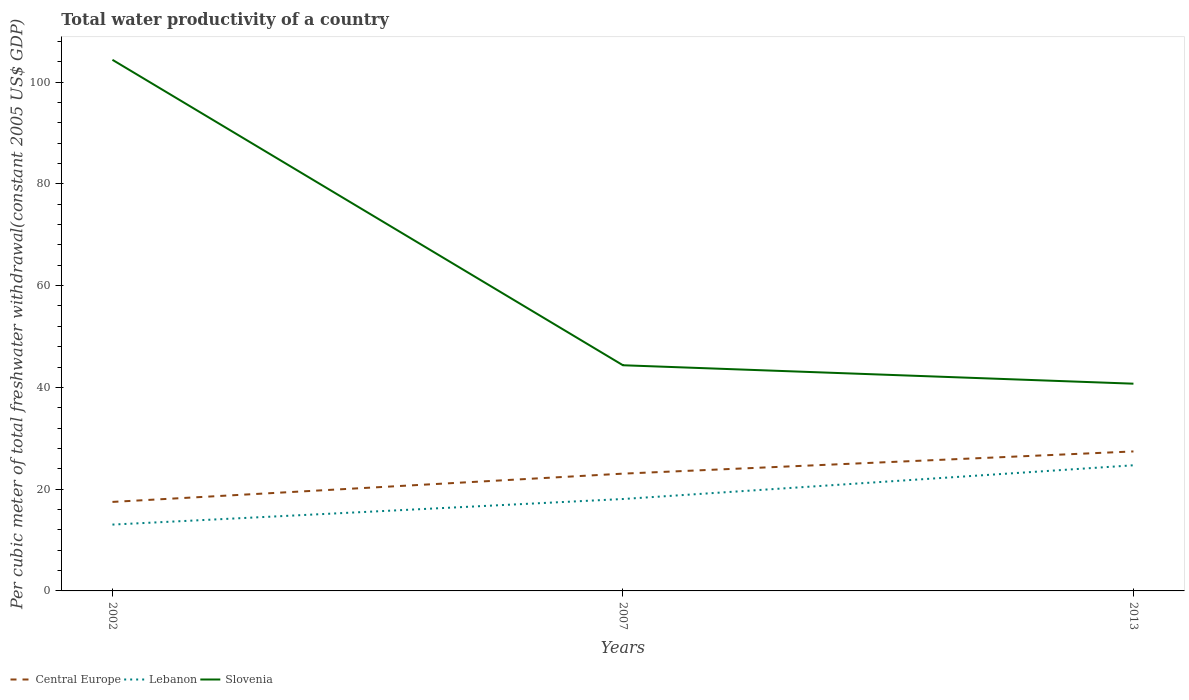How many different coloured lines are there?
Offer a very short reply. 3. Does the line corresponding to Lebanon intersect with the line corresponding to Central Europe?
Give a very brief answer. No. Is the number of lines equal to the number of legend labels?
Offer a very short reply. Yes. Across all years, what is the maximum total water productivity in Central Europe?
Offer a very short reply. 17.49. What is the total total water productivity in Central Europe in the graph?
Your answer should be very brief. -4.37. What is the difference between the highest and the second highest total water productivity in Slovenia?
Offer a terse response. 63.65. What is the difference between the highest and the lowest total water productivity in Central Europe?
Give a very brief answer. 2. How many lines are there?
Your answer should be compact. 3. How many years are there in the graph?
Make the answer very short. 3. What is the difference between two consecutive major ticks on the Y-axis?
Your response must be concise. 20. Are the values on the major ticks of Y-axis written in scientific E-notation?
Ensure brevity in your answer.  No. How are the legend labels stacked?
Offer a terse response. Horizontal. What is the title of the graph?
Your response must be concise. Total water productivity of a country. Does "Bahrain" appear as one of the legend labels in the graph?
Your answer should be compact. No. What is the label or title of the X-axis?
Ensure brevity in your answer.  Years. What is the label or title of the Y-axis?
Make the answer very short. Per cubic meter of total freshwater withdrawal(constant 2005 US$ GDP). What is the Per cubic meter of total freshwater withdrawal(constant 2005 US$ GDP) of Central Europe in 2002?
Provide a short and direct response. 17.49. What is the Per cubic meter of total freshwater withdrawal(constant 2005 US$ GDP) of Lebanon in 2002?
Your answer should be very brief. 13.04. What is the Per cubic meter of total freshwater withdrawal(constant 2005 US$ GDP) of Slovenia in 2002?
Ensure brevity in your answer.  104.38. What is the Per cubic meter of total freshwater withdrawal(constant 2005 US$ GDP) in Central Europe in 2007?
Your answer should be compact. 23.05. What is the Per cubic meter of total freshwater withdrawal(constant 2005 US$ GDP) in Lebanon in 2007?
Give a very brief answer. 18.06. What is the Per cubic meter of total freshwater withdrawal(constant 2005 US$ GDP) of Slovenia in 2007?
Ensure brevity in your answer.  44.35. What is the Per cubic meter of total freshwater withdrawal(constant 2005 US$ GDP) in Central Europe in 2013?
Offer a very short reply. 27.41. What is the Per cubic meter of total freshwater withdrawal(constant 2005 US$ GDP) in Lebanon in 2013?
Your answer should be compact. 24.69. What is the Per cubic meter of total freshwater withdrawal(constant 2005 US$ GDP) in Slovenia in 2013?
Offer a terse response. 40.73. Across all years, what is the maximum Per cubic meter of total freshwater withdrawal(constant 2005 US$ GDP) in Central Europe?
Keep it short and to the point. 27.41. Across all years, what is the maximum Per cubic meter of total freshwater withdrawal(constant 2005 US$ GDP) in Lebanon?
Ensure brevity in your answer.  24.69. Across all years, what is the maximum Per cubic meter of total freshwater withdrawal(constant 2005 US$ GDP) of Slovenia?
Provide a succinct answer. 104.38. Across all years, what is the minimum Per cubic meter of total freshwater withdrawal(constant 2005 US$ GDP) of Central Europe?
Make the answer very short. 17.49. Across all years, what is the minimum Per cubic meter of total freshwater withdrawal(constant 2005 US$ GDP) of Lebanon?
Offer a terse response. 13.04. Across all years, what is the minimum Per cubic meter of total freshwater withdrawal(constant 2005 US$ GDP) in Slovenia?
Offer a very short reply. 40.73. What is the total Per cubic meter of total freshwater withdrawal(constant 2005 US$ GDP) of Central Europe in the graph?
Offer a very short reply. 67.95. What is the total Per cubic meter of total freshwater withdrawal(constant 2005 US$ GDP) in Lebanon in the graph?
Your answer should be compact. 55.79. What is the total Per cubic meter of total freshwater withdrawal(constant 2005 US$ GDP) of Slovenia in the graph?
Keep it short and to the point. 189.45. What is the difference between the Per cubic meter of total freshwater withdrawal(constant 2005 US$ GDP) in Central Europe in 2002 and that in 2007?
Provide a succinct answer. -5.56. What is the difference between the Per cubic meter of total freshwater withdrawal(constant 2005 US$ GDP) in Lebanon in 2002 and that in 2007?
Your response must be concise. -5.03. What is the difference between the Per cubic meter of total freshwater withdrawal(constant 2005 US$ GDP) of Slovenia in 2002 and that in 2007?
Offer a very short reply. 60.02. What is the difference between the Per cubic meter of total freshwater withdrawal(constant 2005 US$ GDP) of Central Europe in 2002 and that in 2013?
Provide a succinct answer. -9.92. What is the difference between the Per cubic meter of total freshwater withdrawal(constant 2005 US$ GDP) in Lebanon in 2002 and that in 2013?
Offer a terse response. -11.66. What is the difference between the Per cubic meter of total freshwater withdrawal(constant 2005 US$ GDP) of Slovenia in 2002 and that in 2013?
Give a very brief answer. 63.65. What is the difference between the Per cubic meter of total freshwater withdrawal(constant 2005 US$ GDP) of Central Europe in 2007 and that in 2013?
Provide a short and direct response. -4.37. What is the difference between the Per cubic meter of total freshwater withdrawal(constant 2005 US$ GDP) in Lebanon in 2007 and that in 2013?
Your answer should be very brief. -6.63. What is the difference between the Per cubic meter of total freshwater withdrawal(constant 2005 US$ GDP) of Slovenia in 2007 and that in 2013?
Your answer should be compact. 3.62. What is the difference between the Per cubic meter of total freshwater withdrawal(constant 2005 US$ GDP) of Central Europe in 2002 and the Per cubic meter of total freshwater withdrawal(constant 2005 US$ GDP) of Lebanon in 2007?
Your answer should be very brief. -0.57. What is the difference between the Per cubic meter of total freshwater withdrawal(constant 2005 US$ GDP) of Central Europe in 2002 and the Per cubic meter of total freshwater withdrawal(constant 2005 US$ GDP) of Slovenia in 2007?
Your answer should be very brief. -26.86. What is the difference between the Per cubic meter of total freshwater withdrawal(constant 2005 US$ GDP) of Lebanon in 2002 and the Per cubic meter of total freshwater withdrawal(constant 2005 US$ GDP) of Slovenia in 2007?
Provide a succinct answer. -31.31. What is the difference between the Per cubic meter of total freshwater withdrawal(constant 2005 US$ GDP) of Central Europe in 2002 and the Per cubic meter of total freshwater withdrawal(constant 2005 US$ GDP) of Lebanon in 2013?
Offer a terse response. -7.2. What is the difference between the Per cubic meter of total freshwater withdrawal(constant 2005 US$ GDP) of Central Europe in 2002 and the Per cubic meter of total freshwater withdrawal(constant 2005 US$ GDP) of Slovenia in 2013?
Your response must be concise. -23.23. What is the difference between the Per cubic meter of total freshwater withdrawal(constant 2005 US$ GDP) in Lebanon in 2002 and the Per cubic meter of total freshwater withdrawal(constant 2005 US$ GDP) in Slovenia in 2013?
Your answer should be very brief. -27.69. What is the difference between the Per cubic meter of total freshwater withdrawal(constant 2005 US$ GDP) of Central Europe in 2007 and the Per cubic meter of total freshwater withdrawal(constant 2005 US$ GDP) of Lebanon in 2013?
Provide a short and direct response. -1.64. What is the difference between the Per cubic meter of total freshwater withdrawal(constant 2005 US$ GDP) of Central Europe in 2007 and the Per cubic meter of total freshwater withdrawal(constant 2005 US$ GDP) of Slovenia in 2013?
Provide a short and direct response. -17.68. What is the difference between the Per cubic meter of total freshwater withdrawal(constant 2005 US$ GDP) of Lebanon in 2007 and the Per cubic meter of total freshwater withdrawal(constant 2005 US$ GDP) of Slovenia in 2013?
Your response must be concise. -22.66. What is the average Per cubic meter of total freshwater withdrawal(constant 2005 US$ GDP) in Central Europe per year?
Ensure brevity in your answer.  22.65. What is the average Per cubic meter of total freshwater withdrawal(constant 2005 US$ GDP) in Lebanon per year?
Make the answer very short. 18.6. What is the average Per cubic meter of total freshwater withdrawal(constant 2005 US$ GDP) of Slovenia per year?
Ensure brevity in your answer.  63.15. In the year 2002, what is the difference between the Per cubic meter of total freshwater withdrawal(constant 2005 US$ GDP) in Central Europe and Per cubic meter of total freshwater withdrawal(constant 2005 US$ GDP) in Lebanon?
Your answer should be compact. 4.46. In the year 2002, what is the difference between the Per cubic meter of total freshwater withdrawal(constant 2005 US$ GDP) of Central Europe and Per cubic meter of total freshwater withdrawal(constant 2005 US$ GDP) of Slovenia?
Your response must be concise. -86.88. In the year 2002, what is the difference between the Per cubic meter of total freshwater withdrawal(constant 2005 US$ GDP) of Lebanon and Per cubic meter of total freshwater withdrawal(constant 2005 US$ GDP) of Slovenia?
Offer a very short reply. -91.34. In the year 2007, what is the difference between the Per cubic meter of total freshwater withdrawal(constant 2005 US$ GDP) in Central Europe and Per cubic meter of total freshwater withdrawal(constant 2005 US$ GDP) in Lebanon?
Offer a terse response. 4.98. In the year 2007, what is the difference between the Per cubic meter of total freshwater withdrawal(constant 2005 US$ GDP) in Central Europe and Per cubic meter of total freshwater withdrawal(constant 2005 US$ GDP) in Slovenia?
Keep it short and to the point. -21.3. In the year 2007, what is the difference between the Per cubic meter of total freshwater withdrawal(constant 2005 US$ GDP) in Lebanon and Per cubic meter of total freshwater withdrawal(constant 2005 US$ GDP) in Slovenia?
Your answer should be compact. -26.29. In the year 2013, what is the difference between the Per cubic meter of total freshwater withdrawal(constant 2005 US$ GDP) of Central Europe and Per cubic meter of total freshwater withdrawal(constant 2005 US$ GDP) of Lebanon?
Offer a very short reply. 2.72. In the year 2013, what is the difference between the Per cubic meter of total freshwater withdrawal(constant 2005 US$ GDP) in Central Europe and Per cubic meter of total freshwater withdrawal(constant 2005 US$ GDP) in Slovenia?
Ensure brevity in your answer.  -13.31. In the year 2013, what is the difference between the Per cubic meter of total freshwater withdrawal(constant 2005 US$ GDP) in Lebanon and Per cubic meter of total freshwater withdrawal(constant 2005 US$ GDP) in Slovenia?
Keep it short and to the point. -16.03. What is the ratio of the Per cubic meter of total freshwater withdrawal(constant 2005 US$ GDP) of Central Europe in 2002 to that in 2007?
Provide a succinct answer. 0.76. What is the ratio of the Per cubic meter of total freshwater withdrawal(constant 2005 US$ GDP) of Lebanon in 2002 to that in 2007?
Your response must be concise. 0.72. What is the ratio of the Per cubic meter of total freshwater withdrawal(constant 2005 US$ GDP) in Slovenia in 2002 to that in 2007?
Give a very brief answer. 2.35. What is the ratio of the Per cubic meter of total freshwater withdrawal(constant 2005 US$ GDP) in Central Europe in 2002 to that in 2013?
Your response must be concise. 0.64. What is the ratio of the Per cubic meter of total freshwater withdrawal(constant 2005 US$ GDP) of Lebanon in 2002 to that in 2013?
Keep it short and to the point. 0.53. What is the ratio of the Per cubic meter of total freshwater withdrawal(constant 2005 US$ GDP) in Slovenia in 2002 to that in 2013?
Give a very brief answer. 2.56. What is the ratio of the Per cubic meter of total freshwater withdrawal(constant 2005 US$ GDP) of Central Europe in 2007 to that in 2013?
Make the answer very short. 0.84. What is the ratio of the Per cubic meter of total freshwater withdrawal(constant 2005 US$ GDP) of Lebanon in 2007 to that in 2013?
Provide a succinct answer. 0.73. What is the ratio of the Per cubic meter of total freshwater withdrawal(constant 2005 US$ GDP) of Slovenia in 2007 to that in 2013?
Give a very brief answer. 1.09. What is the difference between the highest and the second highest Per cubic meter of total freshwater withdrawal(constant 2005 US$ GDP) in Central Europe?
Make the answer very short. 4.37. What is the difference between the highest and the second highest Per cubic meter of total freshwater withdrawal(constant 2005 US$ GDP) in Lebanon?
Keep it short and to the point. 6.63. What is the difference between the highest and the second highest Per cubic meter of total freshwater withdrawal(constant 2005 US$ GDP) of Slovenia?
Offer a very short reply. 60.02. What is the difference between the highest and the lowest Per cubic meter of total freshwater withdrawal(constant 2005 US$ GDP) in Central Europe?
Ensure brevity in your answer.  9.92. What is the difference between the highest and the lowest Per cubic meter of total freshwater withdrawal(constant 2005 US$ GDP) in Lebanon?
Keep it short and to the point. 11.66. What is the difference between the highest and the lowest Per cubic meter of total freshwater withdrawal(constant 2005 US$ GDP) in Slovenia?
Your response must be concise. 63.65. 